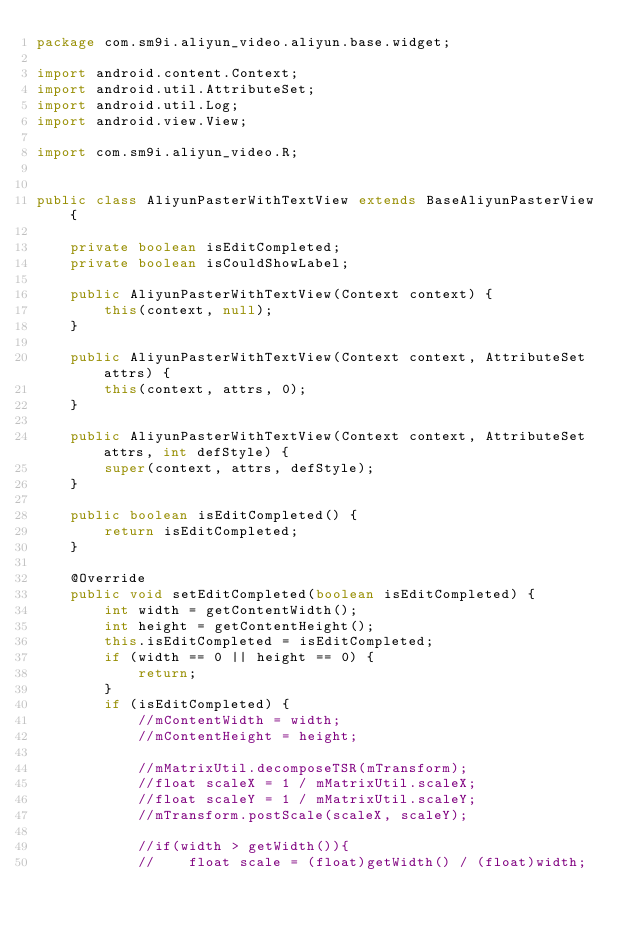Convert code to text. <code><loc_0><loc_0><loc_500><loc_500><_Java_>package com.sm9i.aliyun_video.aliyun.base.widget;

import android.content.Context;
import android.util.AttributeSet;
import android.util.Log;
import android.view.View;

import com.sm9i.aliyun_video.R;


public class AliyunPasterWithTextView extends BaseAliyunPasterView {

    private boolean isEditCompleted;
    private boolean isCouldShowLabel;

    public AliyunPasterWithTextView(Context context) {
        this(context, null);
    }

    public AliyunPasterWithTextView(Context context, AttributeSet attrs) {
        this(context, attrs, 0);
    }

    public AliyunPasterWithTextView(Context context, AttributeSet attrs, int defStyle) {
        super(context, attrs, defStyle);
    }

    public boolean isEditCompleted() {
        return isEditCompleted;
    }

    @Override
    public void setEditCompleted(boolean isEditCompleted) {
        int width = getContentWidth();
        int height = getContentHeight();
        this.isEditCompleted = isEditCompleted;
        if (width == 0 || height == 0) {
            return;
        }
        if (isEditCompleted) {
            //mContentWidth = width;
            //mContentHeight = height;

            //mMatrixUtil.decomposeTSR(mTransform);
            //float scaleX = 1 / mMatrixUtil.scaleX;
            //float scaleY = 1 / mMatrixUtil.scaleY;
            //mTransform.postScale(scaleX, scaleY);

            //if(width > getWidth()){
            //    float scale = (float)getWidth() / (float)width;</code> 